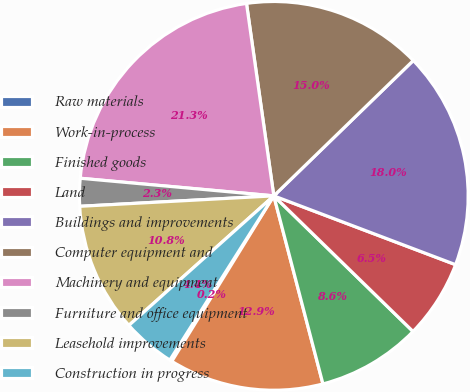Convert chart to OTSL. <chart><loc_0><loc_0><loc_500><loc_500><pie_chart><fcel>Raw materials<fcel>Work-in-process<fcel>Finished goods<fcel>Land<fcel>Buildings and improvements<fcel>Computer equipment and<fcel>Machinery and equipment<fcel>Furniture and office equipment<fcel>Leasehold improvements<fcel>Construction in progress<nl><fcel>0.19%<fcel>12.86%<fcel>8.64%<fcel>6.53%<fcel>18.02%<fcel>14.98%<fcel>21.31%<fcel>2.3%<fcel>10.75%<fcel>4.41%<nl></chart> 